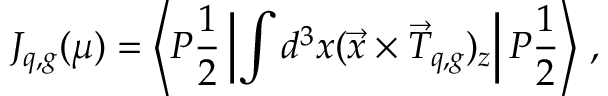<formula> <loc_0><loc_0><loc_500><loc_500>J _ { q , g } ( \mu ) = \left \langle P { \frac { 1 } { 2 } } \left | \int d ^ { 3 } x ( \vec { x } \times \vec { T } _ { q , g } ) _ { z } \right | P { \frac { 1 } { 2 } } \right \rangle \, ,</formula> 